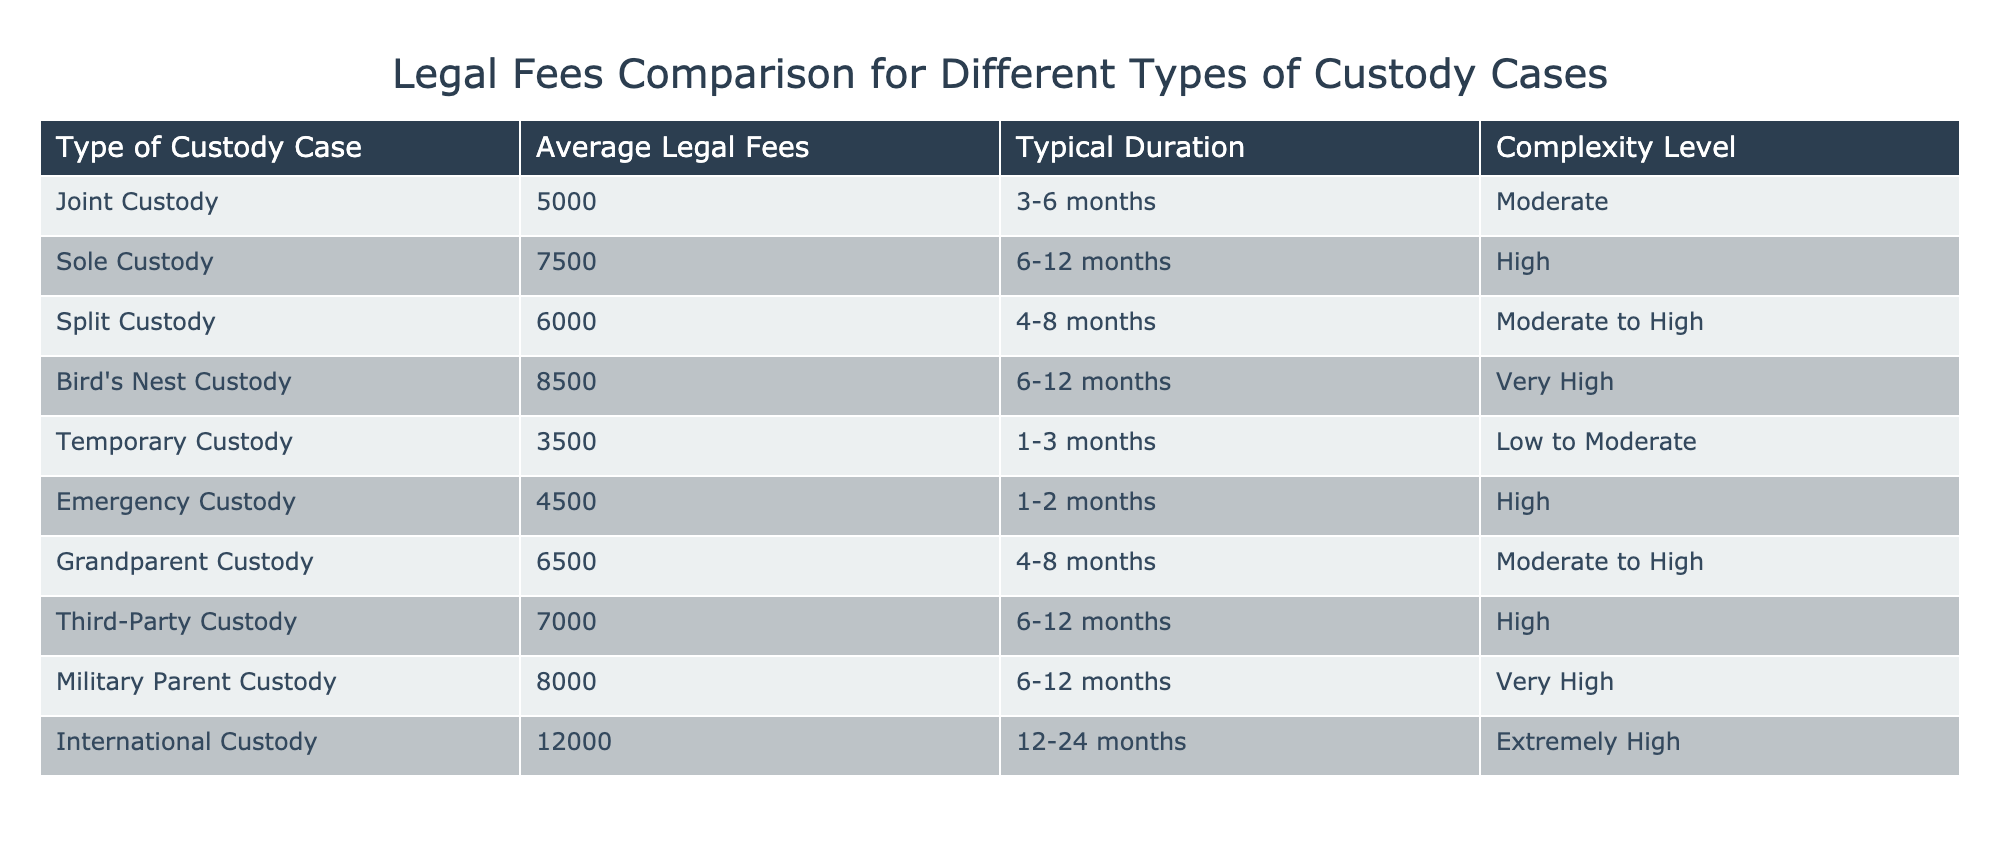What is the average legal fee for a Sole Custody case? The average legal fee for Sole Custody, as specified in the table, is 7500. This value can be found directly in the "Average Legal Fees" column for the Sole Custody row.
Answer: 7500 Which custody case type has the lowest average legal fees? The custody case type with the lowest average legal fees is Temporary Custody, with fees amounting to 3500. This can be identified by comparing all the values in the "Average Legal Fees" column and finding the minimum.
Answer: 3500 True or False: The average legal fee for Bird's Nest Custody is higher than for Joint Custody. The average legal fee for Bird's Nest Custody is 8500, while for Joint Custody, it is 5000. Since 8500 is greater than 5000, the statement is true.
Answer: True What is the total average legal fee for all types of custody cases listed? To find the total average legal fee, we sum up all the fees: 5000 + 7500 + 6000 + 8500 + 3500 + 4500 + 6500 + 7000 + 8000 + 12000 = 57000. There are 10 case types, so the average is 57000 / 10 = 5700.
Answer: 5700 What is the typical duration of a Split Custody case? According to the table, the typical duration of a Split Custody case is 4-8 months. This information is explicitly listed in the "Typical Duration" column for the Split Custody row.
Answer: 4-8 months How much more does Bird's Nest Custody cost on average compared to Temporary Custody? Bird's Nest Custody costs 8500, while Temporary Custody costs 3500. The difference is calculated as 8500 - 3500 = 5000. Therefore, Bird's Nest Custody costs 5000 more than Temporary Custody on average.
Answer: 5000 Which custody case types have a complexity level classified as 'High'? The table specifies that Sole Custody, Emergency Custody, and Third-Party Custody have a complexity level classified as 'High'. This can be determined by filtering the "Complexity Level" column for cases marked as 'High'.
Answer: Sole Custody, Emergency Custody, Third-Party Custody What is the median average legal fee for the custody cases listed? To find the median, we first list the average legal fees in ascending order: 3500, 4500, 5000, 6000, 6500, 7000, 7500, 8000, 8500, 12000. There are 10 values, so the median is the average of the 5th and 6th values: (6500 + 7000) / 2 = 6750.
Answer: 6750 